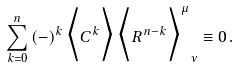Convert formula to latex. <formula><loc_0><loc_0><loc_500><loc_500>\sum _ { k = 0 } ^ { n } \, ( - ) ^ { k } \, \Big < C ^ { k } \Big > \, { \Big < R ^ { n - k } \Big > ^ { \mu } } _ { \nu } \equiv 0 \, .</formula> 